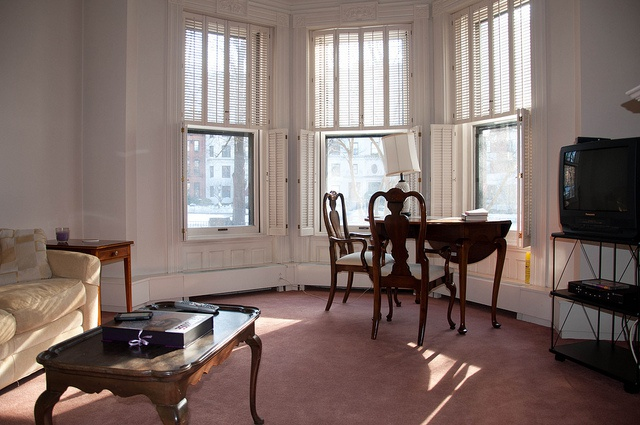Describe the objects in this image and their specific colors. I can see couch in gray, tan, and brown tones, tv in gray and black tones, chair in gray, black, and darkgray tones, dining table in gray, black, lightgray, and maroon tones, and chair in gray, black, darkgray, and white tones in this image. 